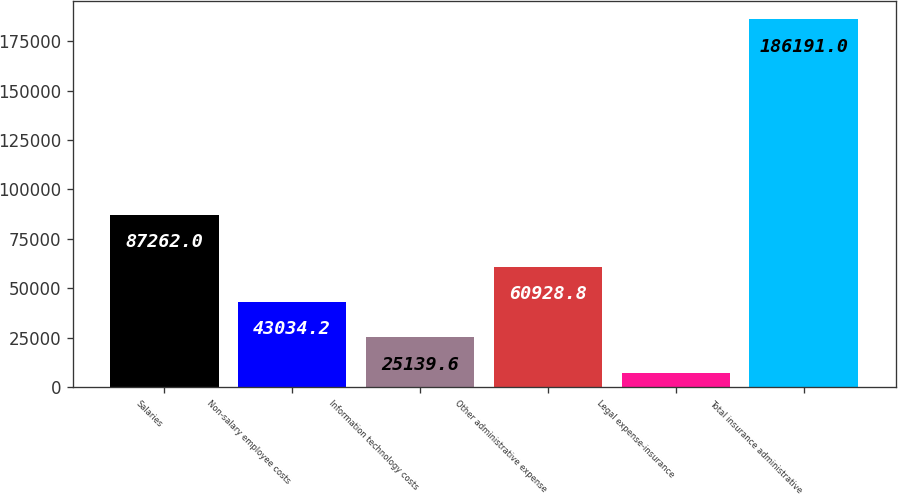<chart> <loc_0><loc_0><loc_500><loc_500><bar_chart><fcel>Salaries<fcel>Non-salary employee costs<fcel>Information technology costs<fcel>Other administrative expense<fcel>Legal expense-insurance<fcel>Total insurance administrative<nl><fcel>87262<fcel>43034.2<fcel>25139.6<fcel>60928.8<fcel>7245<fcel>186191<nl></chart> 